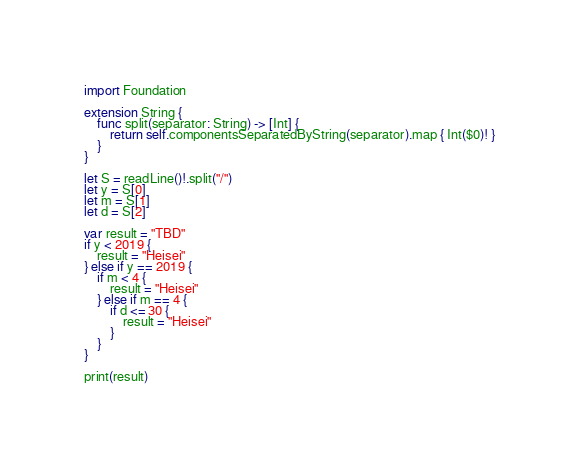Convert code to text. <code><loc_0><loc_0><loc_500><loc_500><_Swift_>import Foundation

extension String {
    func split(separator: String) -> [Int] {
        return self.componentsSeparatedByString(separator).map { Int($0)! }
    }
}

let S = readLine()!.split("/")
let y = S[0]
let m = S[1]
let d = S[2]

var result = "TBD"
if y < 2019 {
    result = "Heisei"
} else if y == 2019 {
    if m < 4 {
        result = "Heisei"
    } else if m == 4 {
        if d <= 30 {
            result = "Heisei"
        }
    }
}

print(result)</code> 